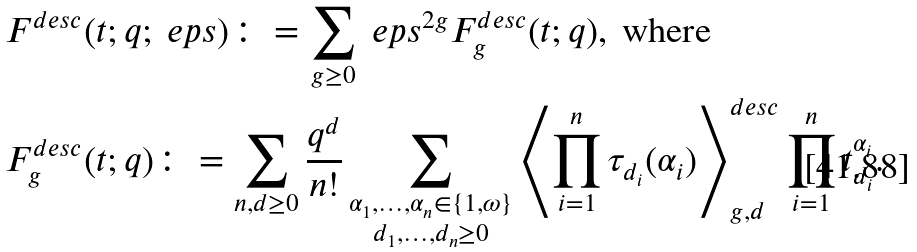<formula> <loc_0><loc_0><loc_500><loc_500>& F ^ { d e s c } ( t ; q ; \ e p s ) \colon = \sum _ { g \geq 0 } \ e p s ^ { 2 g } F ^ { d e s c } _ { g } ( t ; q ) , \text { where} \\ & F ^ { d e s c } _ { g } ( t ; q ) \colon = \sum _ { n , d \geq 0 } \frac { q ^ { d } } { n ! } \sum _ { \substack { \alpha _ { 1 } , \dots , \alpha _ { n } \in \{ 1 , \omega \} \\ d _ { 1 } , \dots , d _ { n } \geq 0 } } \left < \prod _ { i = 1 } ^ { n } \tau _ { d _ { i } } ( \alpha _ { i } ) \right > ^ { d e s c } _ { g , d } \prod _ { i = 1 } ^ { n } t _ { d _ { i } } ^ { \alpha _ { i } } .</formula> 